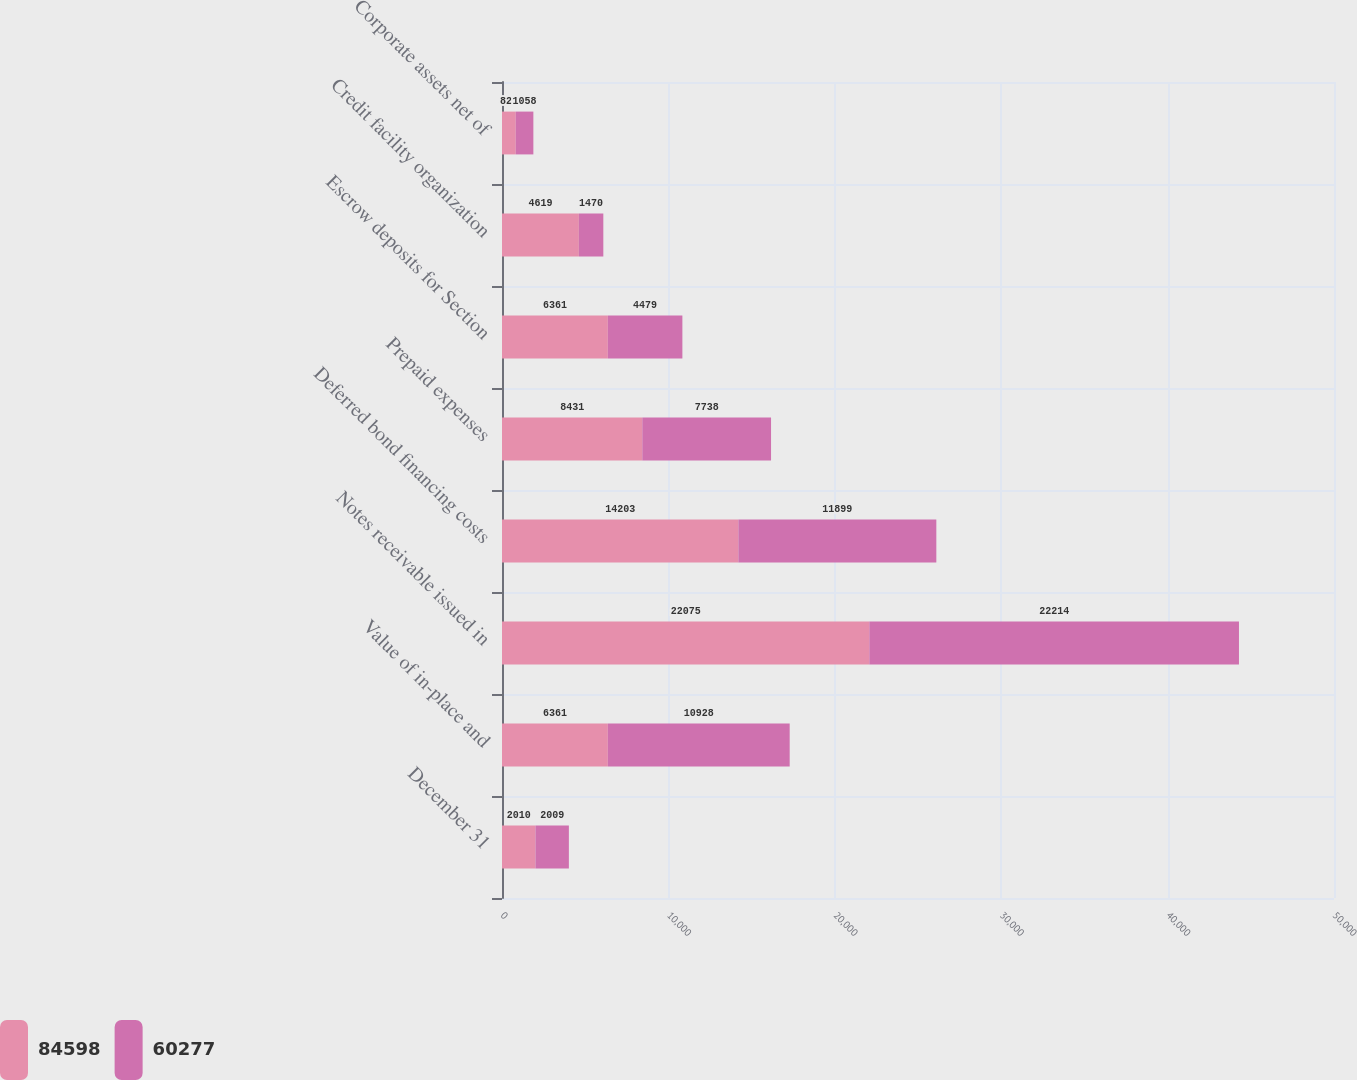Convert chart to OTSL. <chart><loc_0><loc_0><loc_500><loc_500><stacked_bar_chart><ecel><fcel>December 31<fcel>Value of in-place and<fcel>Notes receivable issued in<fcel>Deferred bond financing costs<fcel>Prepaid expenses<fcel>Escrow deposits for Section<fcel>Credit facility organization<fcel>Corporate assets net of<nl><fcel>84598<fcel>2010<fcel>6361<fcel>22075<fcel>14203<fcel>8431<fcel>6361<fcel>4619<fcel>827<nl><fcel>60277<fcel>2009<fcel>10928<fcel>22214<fcel>11899<fcel>7738<fcel>4479<fcel>1470<fcel>1058<nl></chart> 